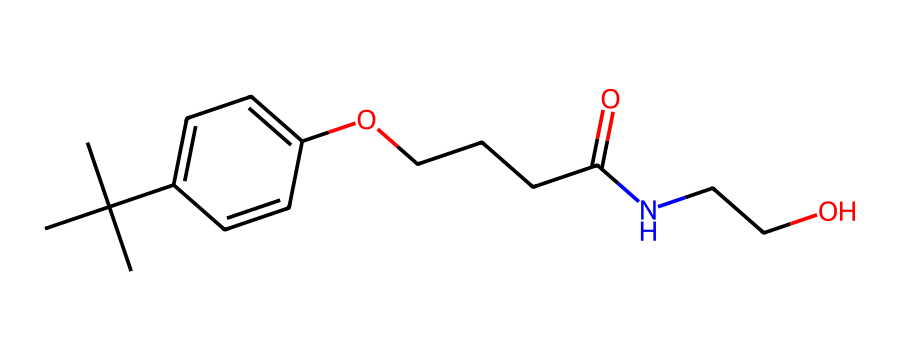What is the primary functional group present in this molecule? The molecule has a hydroxyl group (-OH) attached to a benzene ring, which indicates that it is an alcohol. The presence of the hydroxyl group is a defining characteristic of alcohols.
Answer: alcohol How many carbon atoms are in this molecule? To find the number of carbon atoms, we can count the carbon symbols (C) in the provided SMILES representation. There are 12 occurrences of carbon, indicating there are 12 carbon atoms in total.
Answer: 12 What type of compound is this, based on its structure? This chemical contains both an amide (due to the -NCCO portion) and an ester (due to the C(=O)O section), which indicates that it is a complex lubricant compound, often used for its multi-functional properties.
Answer: lubricant What is the total number of oxygen atoms in this molecule? By counting the oxygen symbols (O) in the SMILES representation, we find that there are 3 oxygen atoms in total: one in the hydroxyl group, one in the ester group, and one in the amide group.
Answer: 3 Which feature of this molecule enhances its lubricating properties? The long carbon chains and the presence of multiple functional groups (like hydroxyl and amide groups) enhance its lubricating properties by providing better interactions with surfaces and improving viscosity.
Answer: long carbon chains What is the significance of the amide group in this compound? The amide group contributes to the compound's ability to interact with biological tissues, making it beneficial for joint lubrication and injury recovery, as it can mimic natural lubricating substances in the body.
Answer: injury recovery 